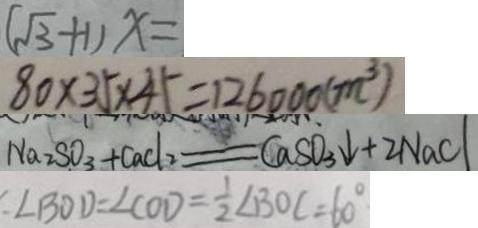Convert formula to latex. <formula><loc_0><loc_0><loc_500><loc_500>( \sqrt { 3 } + 1 ) x = 
 8 0 \times 3 5 \times 4 5 = 1 2 6 0 0 0 ( m ^ { 3 } ) 
 N a 2 S O _ { 3 } + C a C l _ { 2 } = C a S O _ { 3 } \downarrow + 2 N a C l 
 : \angle B O D = \angle C O D = \frac { 1 } { 2 } \angle B O C = 6 0 ^ { \circ }</formula> 